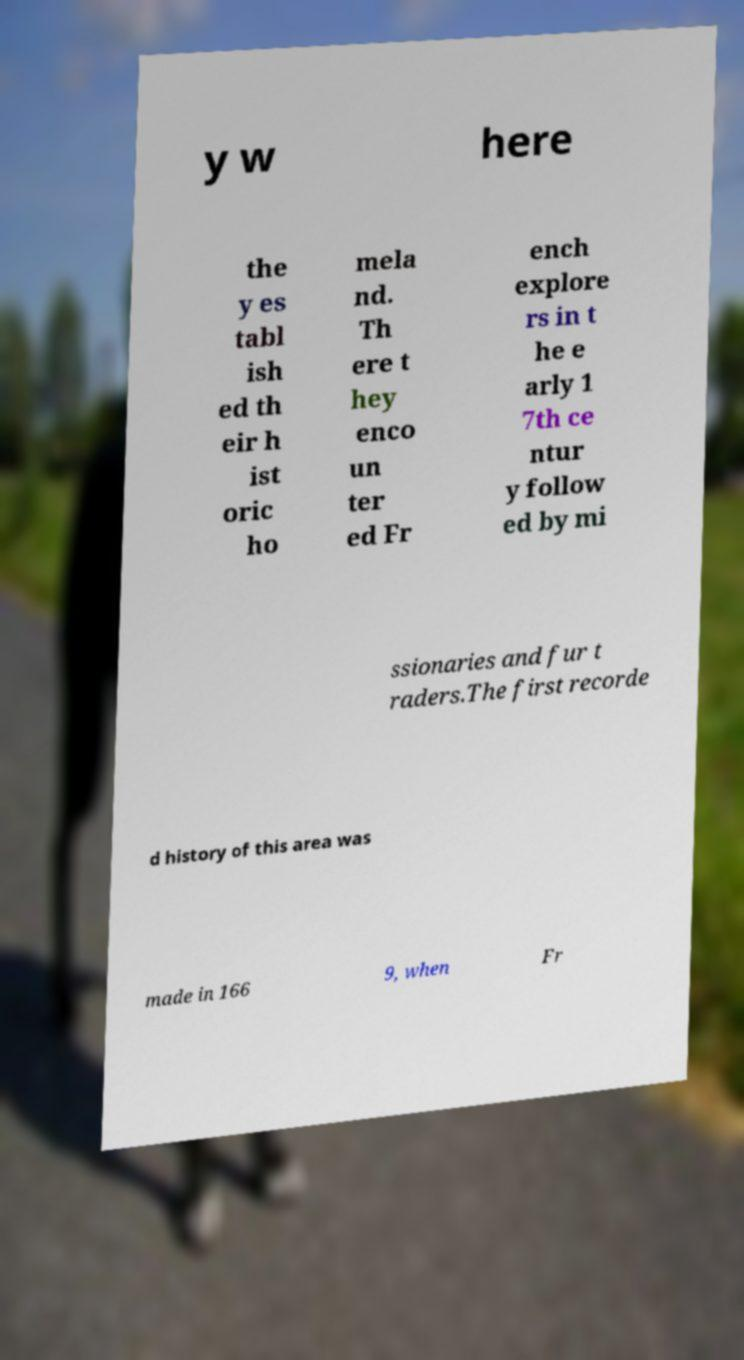Can you read and provide the text displayed in the image?This photo seems to have some interesting text. Can you extract and type it out for me? y w here the y es tabl ish ed th eir h ist oric ho mela nd. Th ere t hey enco un ter ed Fr ench explore rs in t he e arly 1 7th ce ntur y follow ed by mi ssionaries and fur t raders.The first recorde d history of this area was made in 166 9, when Fr 